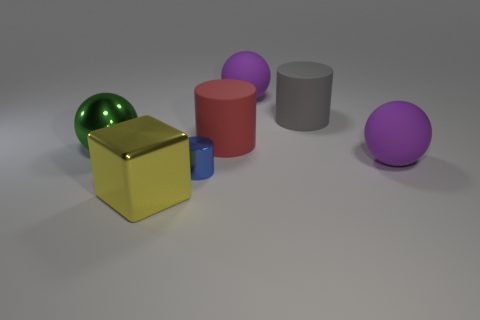Are there any other things that are the same size as the blue shiny object?
Your answer should be compact. No. Is the number of big things that are behind the yellow cube greater than the number of big metallic objects that are on the right side of the tiny blue cylinder?
Provide a succinct answer. Yes. There is a ball that is behind the large gray rubber object; is it the same color as the large thing that is right of the gray matte cylinder?
Make the answer very short. Yes. What shape is the yellow shiny thing that is the same size as the gray rubber thing?
Your answer should be very brief. Cube. Is there a small green matte thing that has the same shape as the green metallic thing?
Provide a succinct answer. No. Does the large purple thing behind the large gray object have the same material as the yellow cube to the left of the big gray cylinder?
Keep it short and to the point. No. What number of large gray things are made of the same material as the big gray cylinder?
Your response must be concise. 0. The shiny cylinder is what color?
Provide a succinct answer. Blue. Is the shape of the large metallic object that is to the left of the big yellow block the same as the big shiny object in front of the blue cylinder?
Your answer should be very brief. No. What color is the rubber sphere that is in front of the big metallic ball?
Your answer should be compact. Purple. 